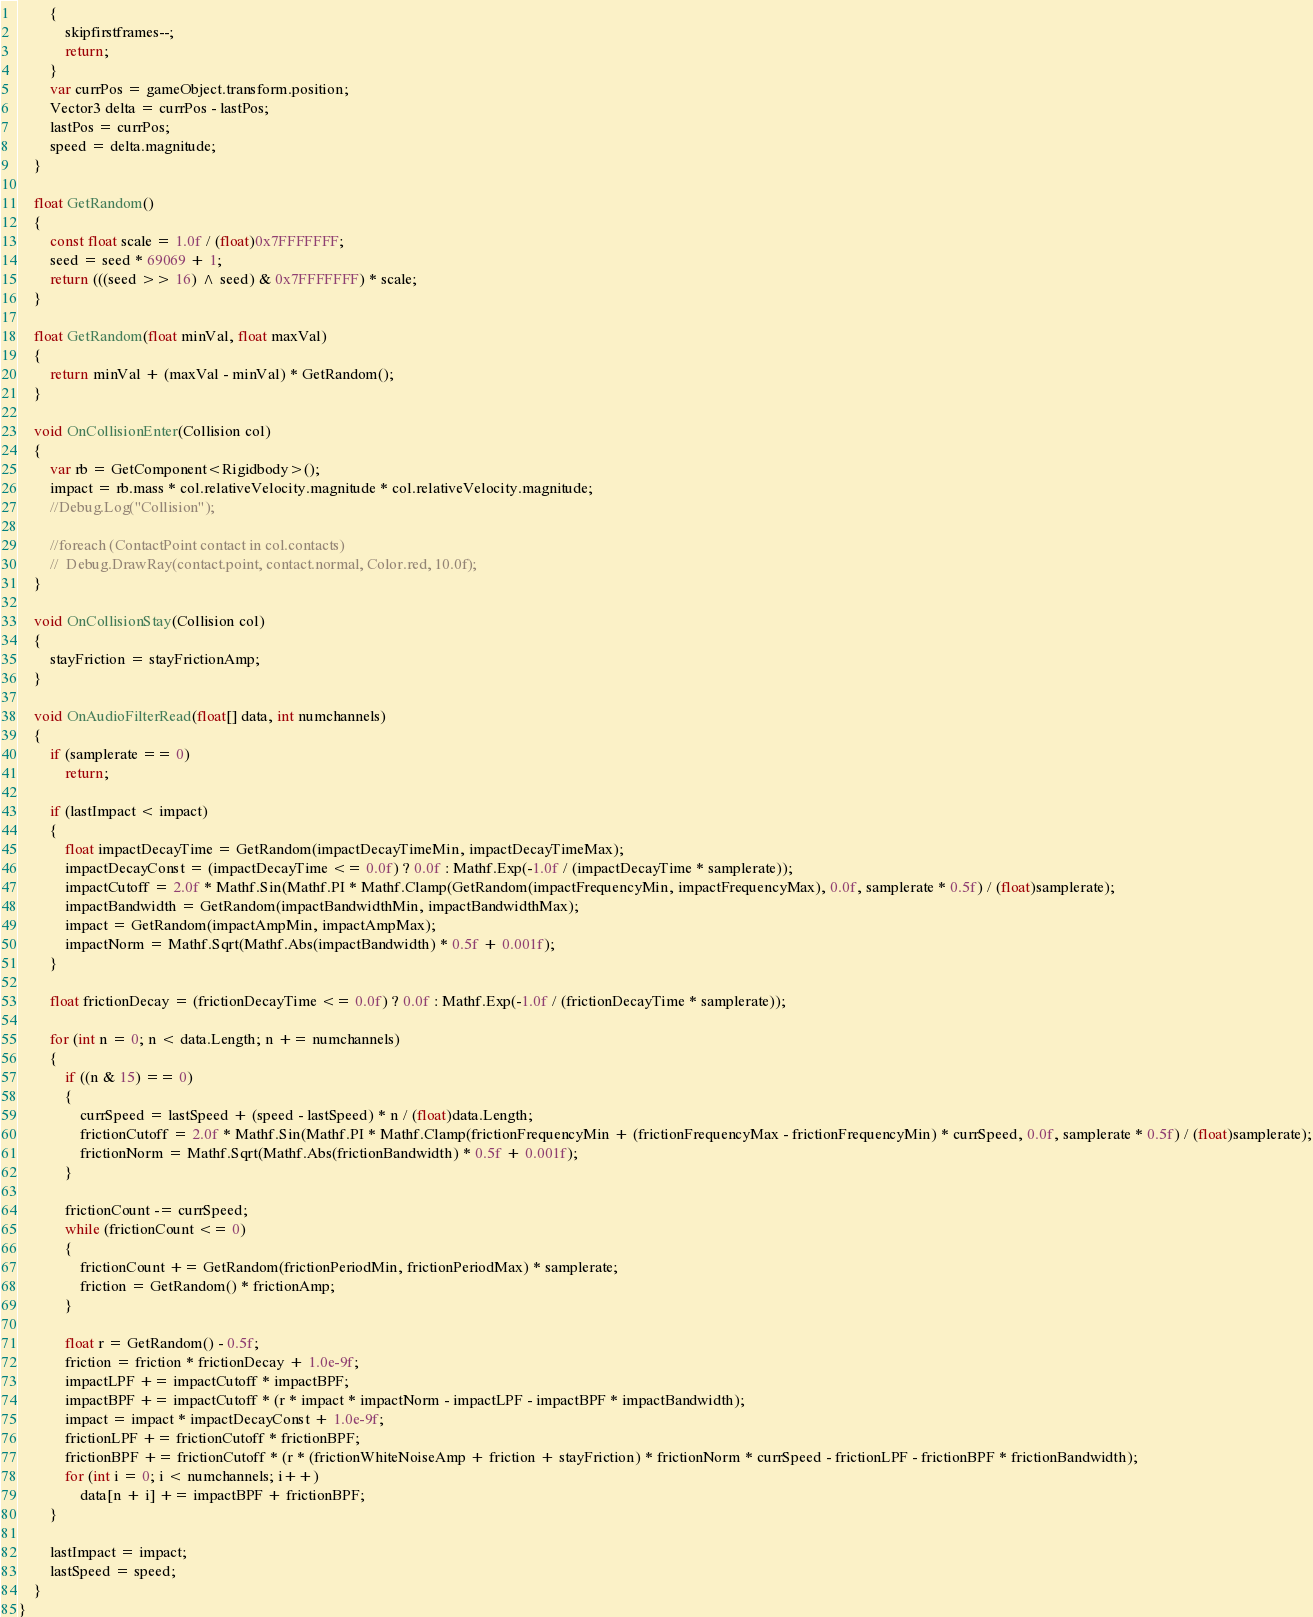Convert code to text. <code><loc_0><loc_0><loc_500><loc_500><_C#_>        {
            skipfirstframes--;
            return;
        }
        var currPos = gameObject.transform.position;
        Vector3 delta = currPos - lastPos;
        lastPos = currPos;
        speed = delta.magnitude;
    }

    float GetRandom()
    {
        const float scale = 1.0f / (float)0x7FFFFFFF;
        seed = seed * 69069 + 1;
        return (((seed >> 16) ^ seed) & 0x7FFFFFFF) * scale;
    }

    float GetRandom(float minVal, float maxVal)
    {
        return minVal + (maxVal - minVal) * GetRandom();
    }

    void OnCollisionEnter(Collision col)
    {
        var rb = GetComponent<Rigidbody>();
        impact = rb.mass * col.relativeVelocity.magnitude * col.relativeVelocity.magnitude;
        //Debug.Log("Collision");

        //foreach (ContactPoint contact in col.contacts)
        //  Debug.DrawRay(contact.point, contact.normal, Color.red, 10.0f);
    }

    void OnCollisionStay(Collision col)
    {
        stayFriction = stayFrictionAmp;
    }

    void OnAudioFilterRead(float[] data, int numchannels)
    {
        if (samplerate == 0)
            return;

        if (lastImpact < impact)
        {
            float impactDecayTime = GetRandom(impactDecayTimeMin, impactDecayTimeMax);
            impactDecayConst = (impactDecayTime <= 0.0f) ? 0.0f : Mathf.Exp(-1.0f / (impactDecayTime * samplerate));
            impactCutoff = 2.0f * Mathf.Sin(Mathf.PI * Mathf.Clamp(GetRandom(impactFrequencyMin, impactFrequencyMax), 0.0f, samplerate * 0.5f) / (float)samplerate);
            impactBandwidth = GetRandom(impactBandwidthMin, impactBandwidthMax);
            impact = GetRandom(impactAmpMin, impactAmpMax);
            impactNorm = Mathf.Sqrt(Mathf.Abs(impactBandwidth) * 0.5f + 0.001f);
        }

        float frictionDecay = (frictionDecayTime <= 0.0f) ? 0.0f : Mathf.Exp(-1.0f / (frictionDecayTime * samplerate));

        for (int n = 0; n < data.Length; n += numchannels)
        {
            if ((n & 15) == 0)
            {
                currSpeed = lastSpeed + (speed - lastSpeed) * n / (float)data.Length;
                frictionCutoff = 2.0f * Mathf.Sin(Mathf.PI * Mathf.Clamp(frictionFrequencyMin + (frictionFrequencyMax - frictionFrequencyMin) * currSpeed, 0.0f, samplerate * 0.5f) / (float)samplerate);
                frictionNorm = Mathf.Sqrt(Mathf.Abs(frictionBandwidth) * 0.5f + 0.001f);
            }

            frictionCount -= currSpeed;
            while (frictionCount <= 0)
            {
                frictionCount += GetRandom(frictionPeriodMin, frictionPeriodMax) * samplerate;
                friction = GetRandom() * frictionAmp;
            }

            float r = GetRandom() - 0.5f;
            friction = friction * frictionDecay + 1.0e-9f;
            impactLPF += impactCutoff * impactBPF;
            impactBPF += impactCutoff * (r * impact * impactNorm - impactLPF - impactBPF * impactBandwidth);
            impact = impact * impactDecayConst + 1.0e-9f;
            frictionLPF += frictionCutoff * frictionBPF;
            frictionBPF += frictionCutoff * (r * (frictionWhiteNoiseAmp + friction + stayFriction) * frictionNorm * currSpeed - frictionLPF - frictionBPF * frictionBandwidth);
            for (int i = 0; i < numchannels; i++)
                data[n + i] += impactBPF + frictionBPF;
        }

        lastImpact = impact;
        lastSpeed = speed;
    }
}
</code> 